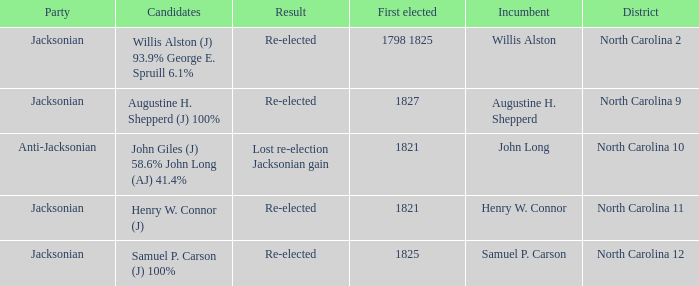Name the total number of party for willis alston 1.0. 